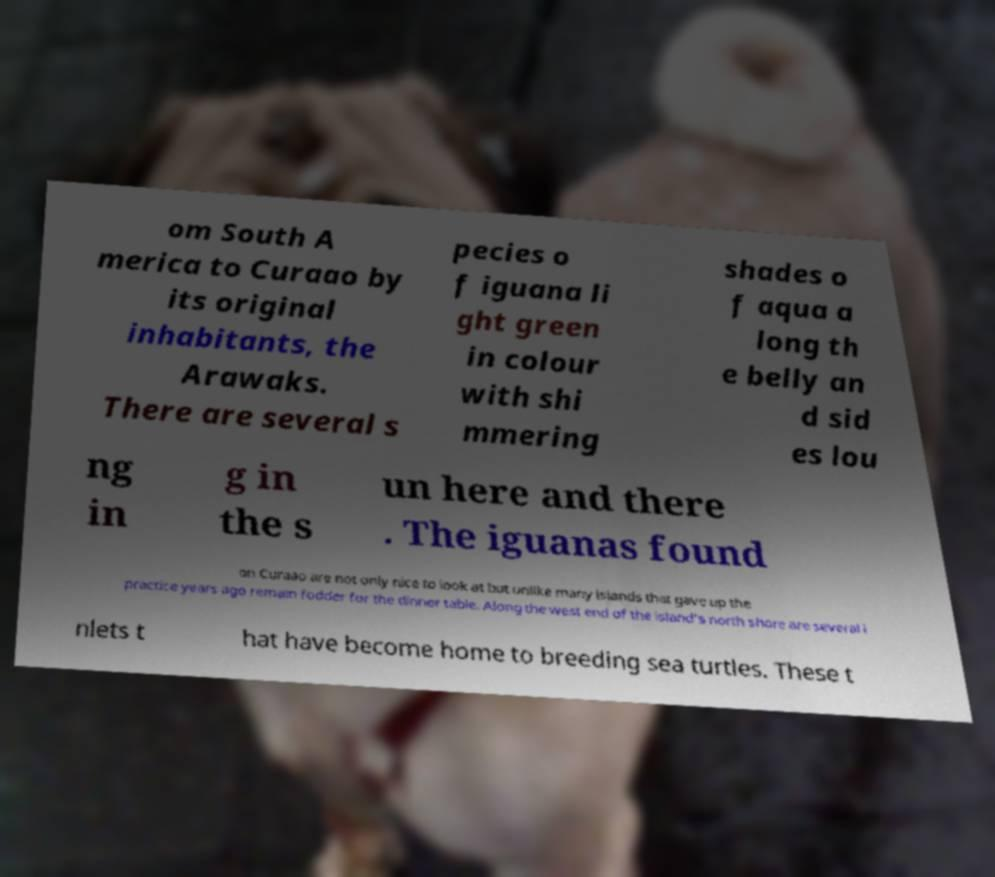Could you extract and type out the text from this image? om South A merica to Curaao by its original inhabitants, the Arawaks. There are several s pecies o f iguana li ght green in colour with shi mmering shades o f aqua a long th e belly an d sid es lou ng in g in the s un here and there . The iguanas found on Curaao are not only nice to look at but unlike many islands that gave up the practice years ago remain fodder for the dinner table. Along the west end of the island's north shore are several i nlets t hat have become home to breeding sea turtles. These t 